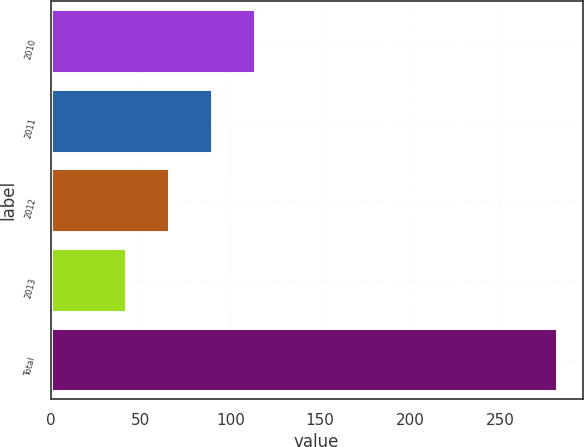<chart> <loc_0><loc_0><loc_500><loc_500><bar_chart><fcel>2010<fcel>2011<fcel>2012<fcel>2013<fcel>Total<nl><fcel>114<fcel>90<fcel>66<fcel>42<fcel>282<nl></chart> 